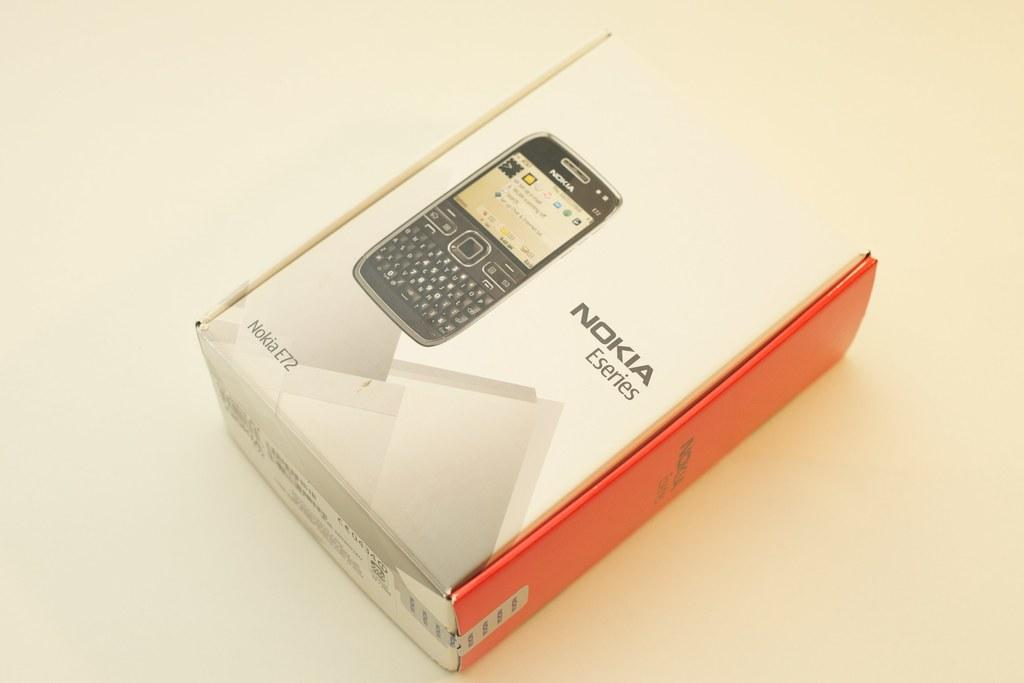Provide a one-sentence caption for the provided image. A box that contains a Nokia Eseries phone rests on a table. 